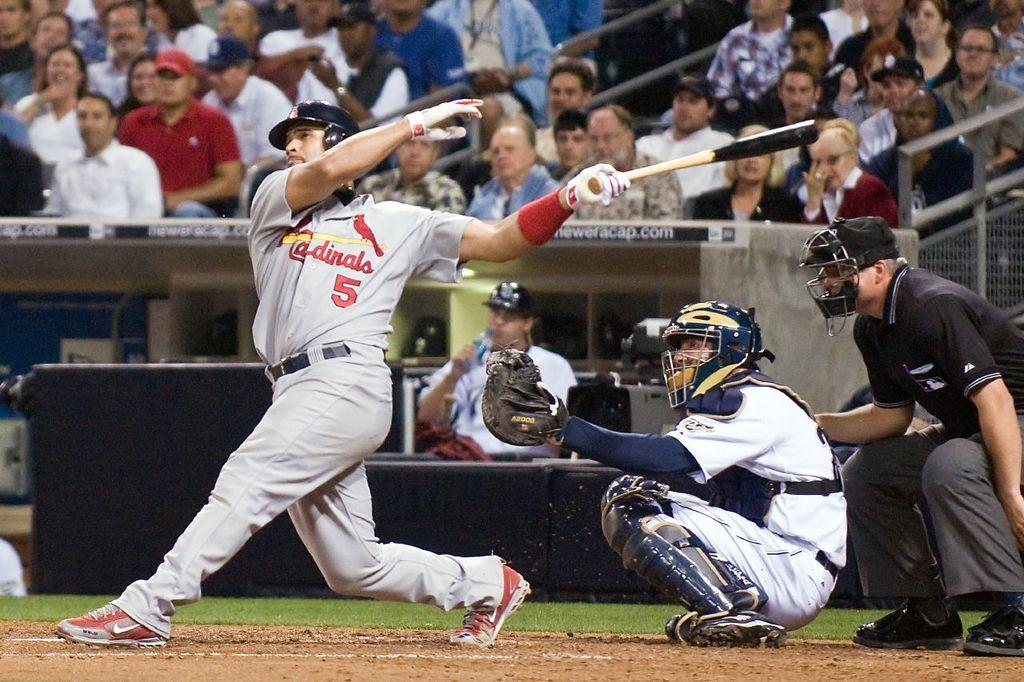<image>
Give a short and clear explanation of the subsequent image. a man hitting a ball from the Cardinals baseball team 